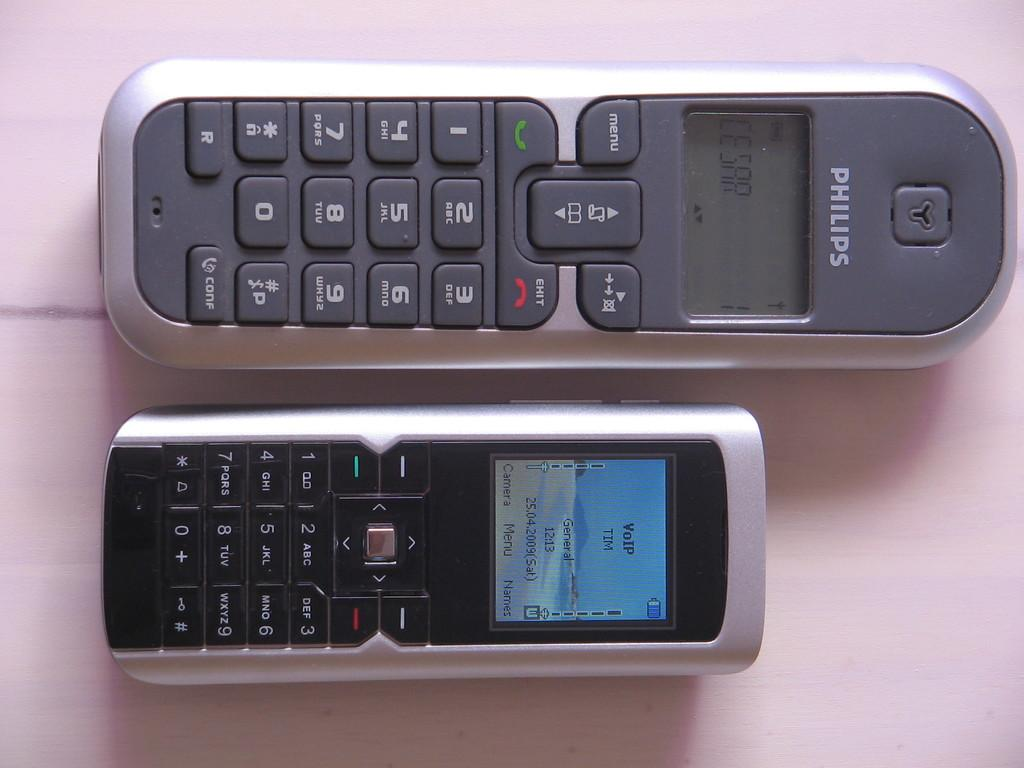<image>
Render a clear and concise summary of the photo. A picture of two phones one of which is a Phillips phone 